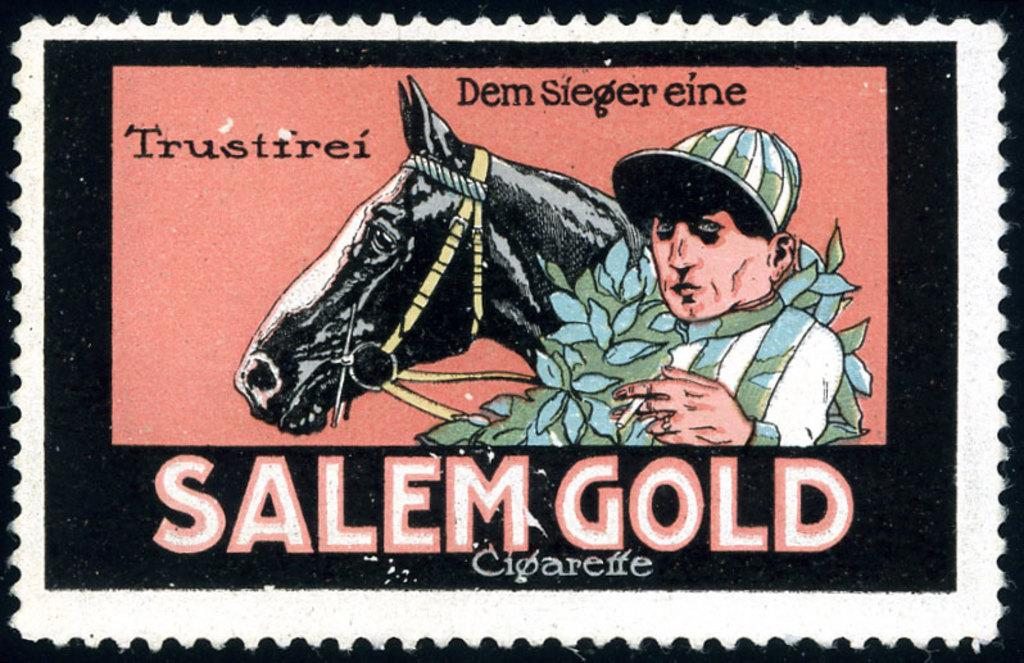What object is the main subject of the image? There is a stamp in the image. What images are depicted on the stamp? The stamp has images of a horse and a man. Is there any text on the stamp? Yes, there is text below the images on the stamp. How many umbrellas are shown on the stamp? There are no umbrellas depicted on the stamp; it features images of a horse and a man. What type of beetle can be seen crawling on the text of the stamp? There is no beetle present on the stamp; it only features images of a horse and a man, along with text. 